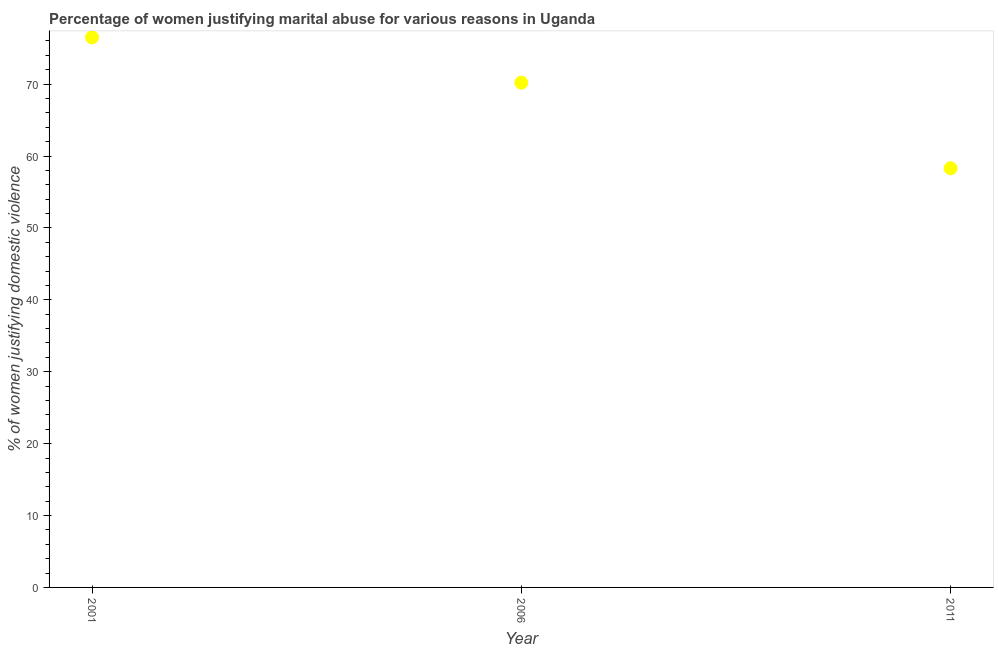What is the percentage of women justifying marital abuse in 2001?
Make the answer very short. 76.5. Across all years, what is the maximum percentage of women justifying marital abuse?
Provide a short and direct response. 76.5. Across all years, what is the minimum percentage of women justifying marital abuse?
Ensure brevity in your answer.  58.3. In which year was the percentage of women justifying marital abuse minimum?
Your response must be concise. 2011. What is the sum of the percentage of women justifying marital abuse?
Your answer should be compact. 205. What is the difference between the percentage of women justifying marital abuse in 2001 and 2011?
Ensure brevity in your answer.  18.2. What is the average percentage of women justifying marital abuse per year?
Offer a very short reply. 68.33. What is the median percentage of women justifying marital abuse?
Provide a short and direct response. 70.2. What is the ratio of the percentage of women justifying marital abuse in 2001 to that in 2006?
Ensure brevity in your answer.  1.09. Is the difference between the percentage of women justifying marital abuse in 2001 and 2006 greater than the difference between any two years?
Give a very brief answer. No. What is the difference between the highest and the second highest percentage of women justifying marital abuse?
Your response must be concise. 6.3. What is the difference between the highest and the lowest percentage of women justifying marital abuse?
Give a very brief answer. 18.2. How many years are there in the graph?
Your answer should be very brief. 3. What is the difference between two consecutive major ticks on the Y-axis?
Give a very brief answer. 10. Are the values on the major ticks of Y-axis written in scientific E-notation?
Ensure brevity in your answer.  No. Does the graph contain any zero values?
Offer a very short reply. No. Does the graph contain grids?
Your response must be concise. No. What is the title of the graph?
Ensure brevity in your answer.  Percentage of women justifying marital abuse for various reasons in Uganda. What is the label or title of the X-axis?
Your response must be concise. Year. What is the label or title of the Y-axis?
Give a very brief answer. % of women justifying domestic violence. What is the % of women justifying domestic violence in 2001?
Your answer should be compact. 76.5. What is the % of women justifying domestic violence in 2006?
Keep it short and to the point. 70.2. What is the % of women justifying domestic violence in 2011?
Ensure brevity in your answer.  58.3. What is the difference between the % of women justifying domestic violence in 2001 and 2006?
Give a very brief answer. 6.3. What is the difference between the % of women justifying domestic violence in 2001 and 2011?
Offer a very short reply. 18.2. What is the difference between the % of women justifying domestic violence in 2006 and 2011?
Make the answer very short. 11.9. What is the ratio of the % of women justifying domestic violence in 2001 to that in 2006?
Keep it short and to the point. 1.09. What is the ratio of the % of women justifying domestic violence in 2001 to that in 2011?
Give a very brief answer. 1.31. What is the ratio of the % of women justifying domestic violence in 2006 to that in 2011?
Your response must be concise. 1.2. 